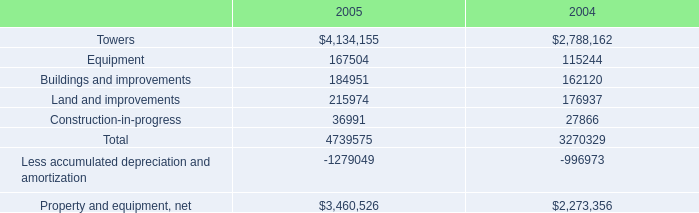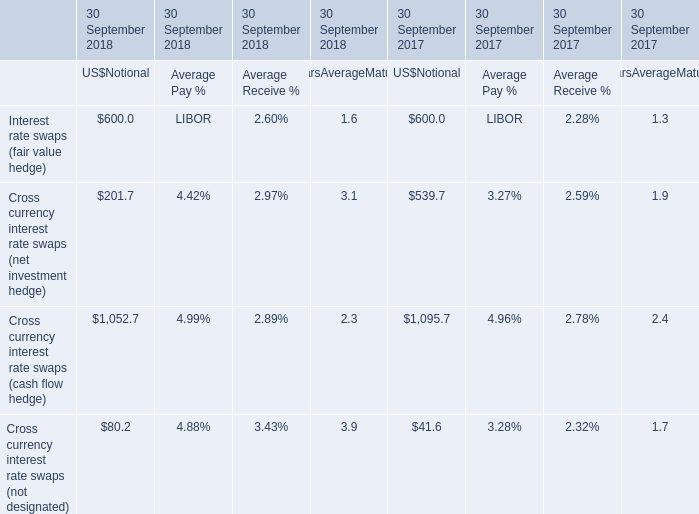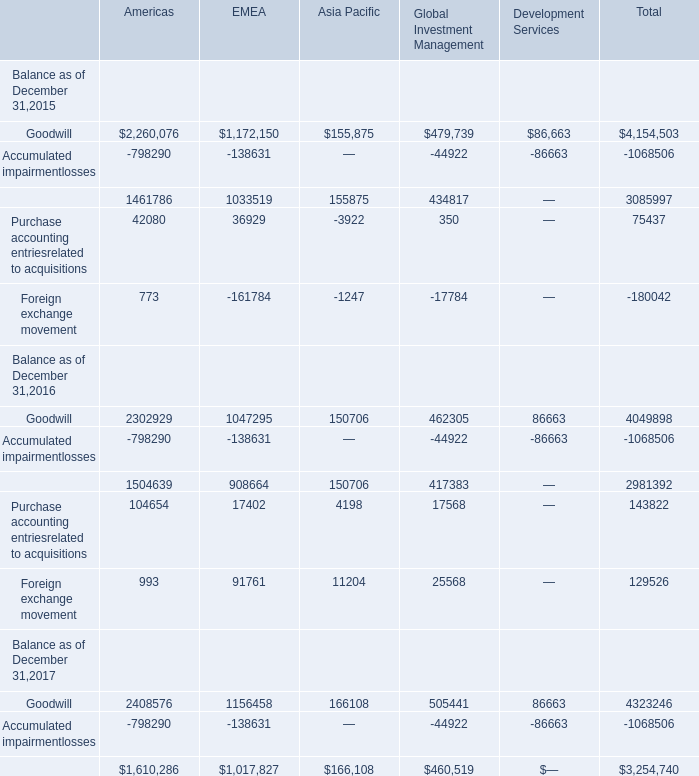What is the average amount of Goodwill Balance as of December 31,2017 of Americas, and Less accumulated depreciation and amortization of 2005 ? 
Computations: ((2408576.0 + 1279049.0) / 2)
Answer: 1843812.5. 